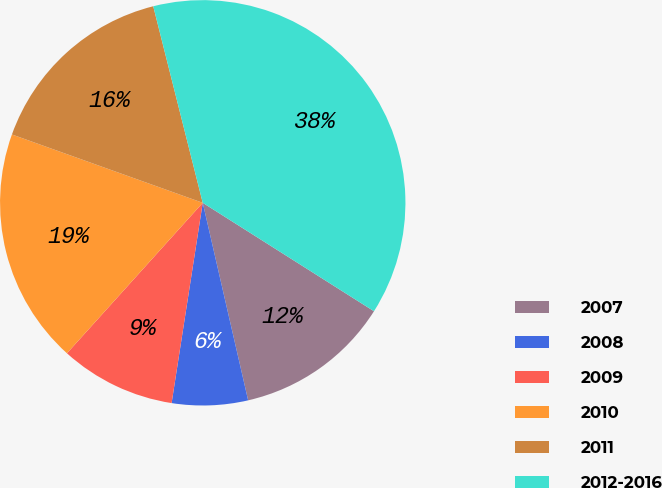<chart> <loc_0><loc_0><loc_500><loc_500><pie_chart><fcel>2007<fcel>2008<fcel>2009<fcel>2010<fcel>2011<fcel>2012-2016<nl><fcel>12.42%<fcel>6.05%<fcel>9.23%<fcel>18.79%<fcel>15.6%<fcel>37.91%<nl></chart> 